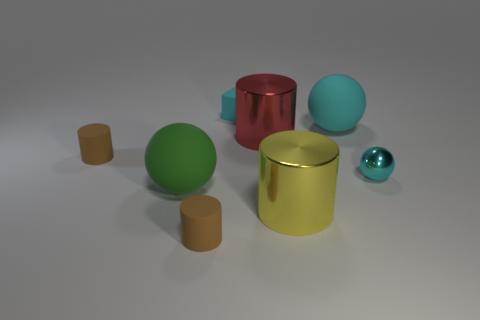Subtract 1 spheres. How many spheres are left? 2 Add 2 large gray metallic blocks. How many objects exist? 10 Subtract all yellow cylinders. How many cylinders are left? 3 Subtract all rubber spheres. How many spheres are left? 1 Subtract all purple cylinders. Subtract all yellow blocks. How many cylinders are left? 4 Subtract all blocks. How many objects are left? 7 Add 2 red objects. How many red objects exist? 3 Subtract 0 brown cubes. How many objects are left? 8 Subtract all big yellow shiny things. Subtract all big matte spheres. How many objects are left? 5 Add 1 big yellow cylinders. How many big yellow cylinders are left? 2 